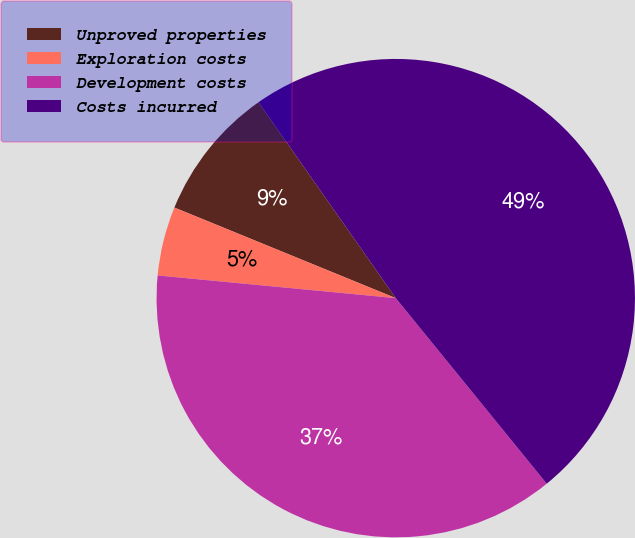Convert chart. <chart><loc_0><loc_0><loc_500><loc_500><pie_chart><fcel>Unproved properties<fcel>Exploration costs<fcel>Development costs<fcel>Costs incurred<nl><fcel>9.09%<fcel>4.67%<fcel>37.38%<fcel>48.86%<nl></chart> 